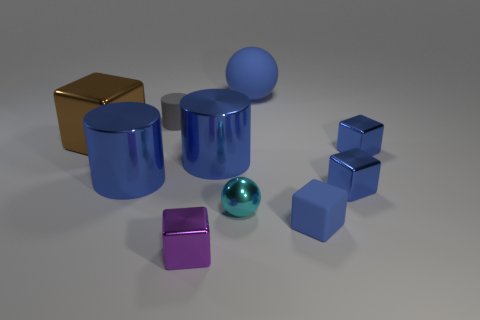Subtract all cyan spheres. How many blue cubes are left? 3 Subtract all matte blocks. How many blocks are left? 4 Subtract all purple blocks. How many blocks are left? 4 Subtract all cyan cubes. Subtract all red cylinders. How many cubes are left? 5 Subtract all cylinders. How many objects are left? 7 Add 5 large blue spheres. How many large blue spheres are left? 6 Add 8 cyan matte cubes. How many cyan matte cubes exist? 8 Subtract 0 cyan cylinders. How many objects are left? 10 Subtract all purple objects. Subtract all big brown metal blocks. How many objects are left? 8 